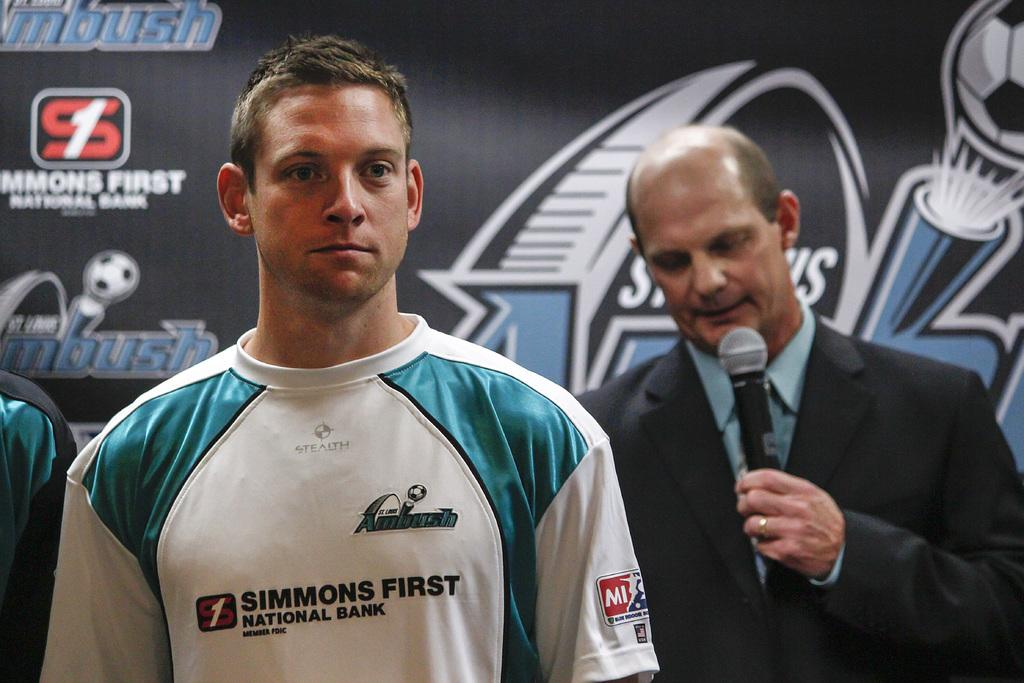<image>
Render a clear and concise summary of the photo. A reporter interviewing a man wearing aa Ambush soccer shirt featuring Simmons First National Bank. 